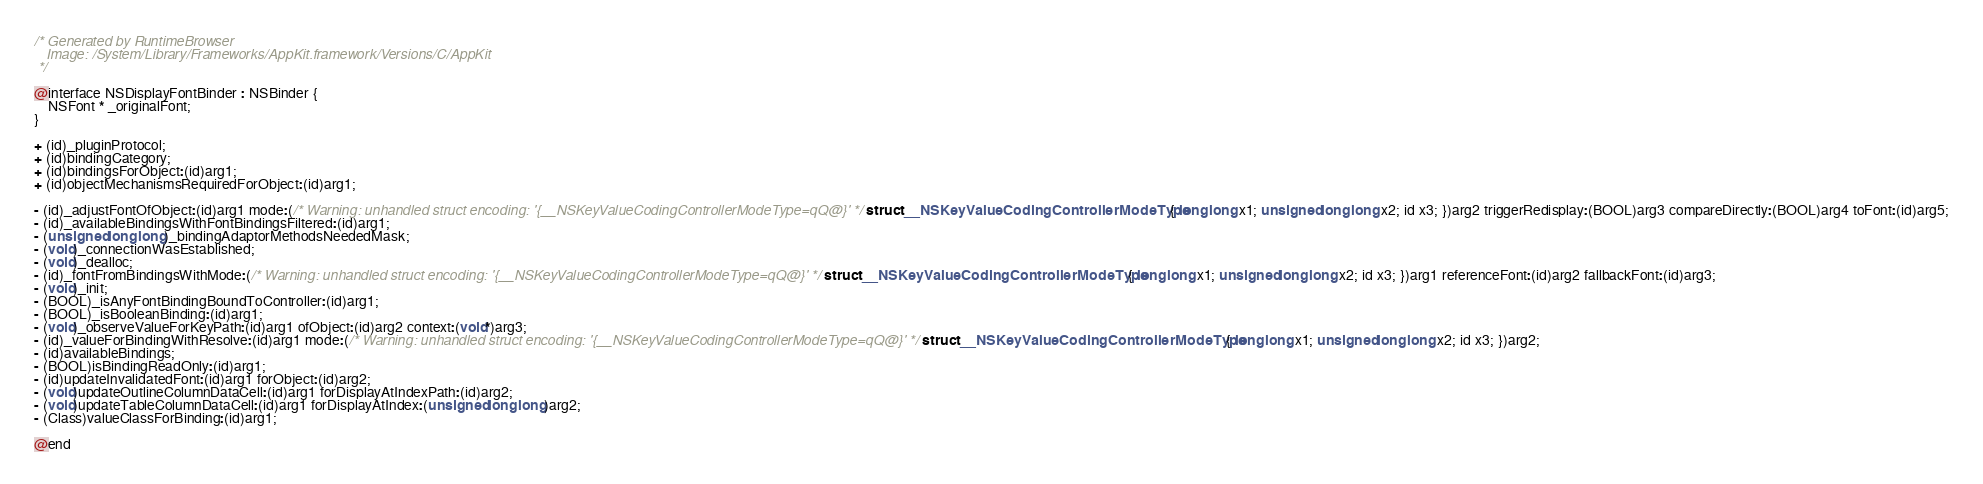<code> <loc_0><loc_0><loc_500><loc_500><_C_>/* Generated by RuntimeBrowser
   Image: /System/Library/Frameworks/AppKit.framework/Versions/C/AppKit
 */

@interface NSDisplayFontBinder : NSBinder {
    NSFont * _originalFont;
}

+ (id)_pluginProtocol;
+ (id)bindingCategory;
+ (id)bindingsForObject:(id)arg1;
+ (id)objectMechanismsRequiredForObject:(id)arg1;

- (id)_adjustFontOfObject:(id)arg1 mode:(/* Warning: unhandled struct encoding: '{__NSKeyValueCodingControllerModeType=qQ@}' */ struct __NSKeyValueCodingControllerModeType { long long x1; unsigned long long x2; id x3; })arg2 triggerRedisplay:(BOOL)arg3 compareDirectly:(BOOL)arg4 toFont:(id)arg5;
- (id)_availableBindingsWithFontBindingsFiltered:(id)arg1;
- (unsigned long long)_bindingAdaptorMethodsNeededMask;
- (void)_connectionWasEstablished;
- (void)_dealloc;
- (id)_fontFromBindingsWithMode:(/* Warning: unhandled struct encoding: '{__NSKeyValueCodingControllerModeType=qQ@}' */ struct __NSKeyValueCodingControllerModeType { long long x1; unsigned long long x2; id x3; })arg1 referenceFont:(id)arg2 fallbackFont:(id)arg3;
- (void)_init;
- (BOOL)_isAnyFontBindingBoundToController:(id)arg1;
- (BOOL)_isBooleanBinding:(id)arg1;
- (void)_observeValueForKeyPath:(id)arg1 ofObject:(id)arg2 context:(void*)arg3;
- (id)_valueForBindingWithResolve:(id)arg1 mode:(/* Warning: unhandled struct encoding: '{__NSKeyValueCodingControllerModeType=qQ@}' */ struct __NSKeyValueCodingControllerModeType { long long x1; unsigned long long x2; id x3; })arg2;
- (id)availableBindings;
- (BOOL)isBindingReadOnly:(id)arg1;
- (id)updateInvalidatedFont:(id)arg1 forObject:(id)arg2;
- (void)updateOutlineColumnDataCell:(id)arg1 forDisplayAtIndexPath:(id)arg2;
- (void)updateTableColumnDataCell:(id)arg1 forDisplayAtIndex:(unsigned long long)arg2;
- (Class)valueClassForBinding:(id)arg1;

@end
</code> 